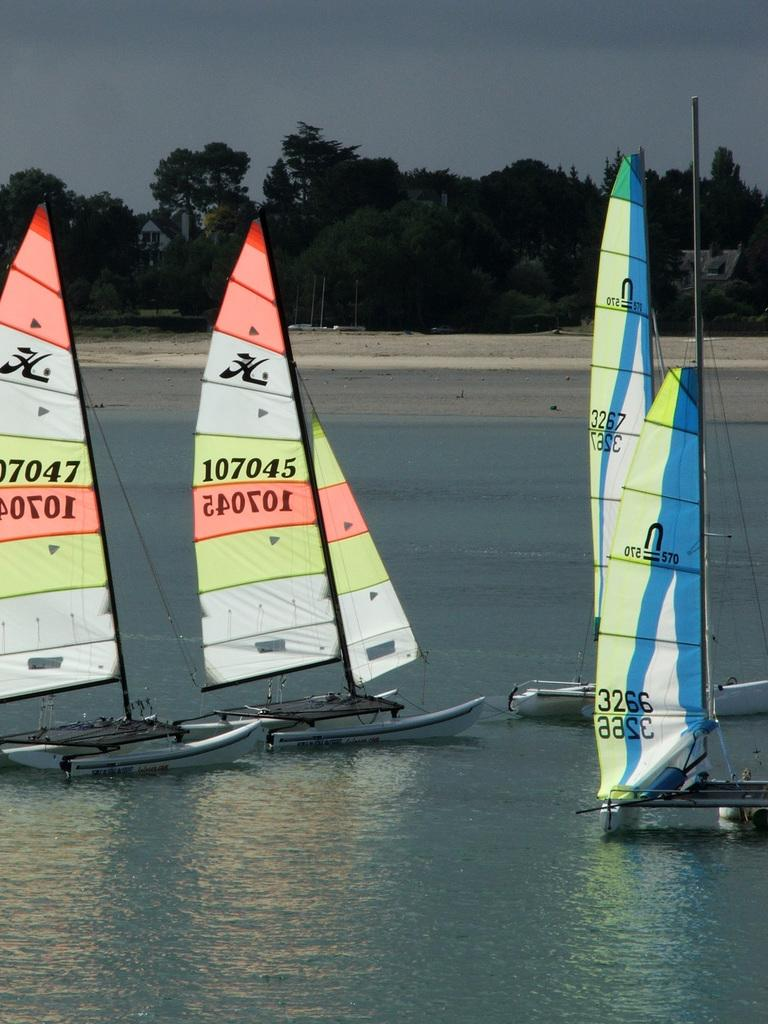<image>
Offer a succinct explanation of the picture presented. Four sailboats, one that says 107045 on it. 